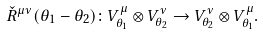<formula> <loc_0><loc_0><loc_500><loc_500>\check { R } ^ { \mu \nu } ( \theta _ { 1 } - \theta _ { 2 } ) \colon V ^ { \mu } _ { \theta _ { 1 } } \otimes V ^ { \nu } _ { \theta _ { 2 } } \to V ^ { \nu } _ { \theta _ { 2 } } \otimes V ^ { \mu } _ { \theta _ { 1 } } .</formula> 